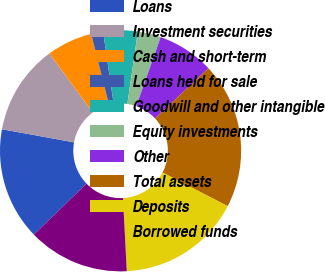<chart> <loc_0><loc_0><loc_500><loc_500><pie_chart><fcel>Loans<fcel>Investment securities<fcel>Cash and short-term<fcel>Loans held for sale<fcel>Goodwill and other intangible<fcel>Equity investments<fcel>Other<fcel>Total assets<fcel>Deposits<fcel>Borrowed funds<nl><fcel>15.09%<fcel>12.1%<fcel>6.11%<fcel>1.61%<fcel>4.61%<fcel>3.11%<fcel>7.6%<fcel>19.59%<fcel>16.59%<fcel>13.59%<nl></chart> 